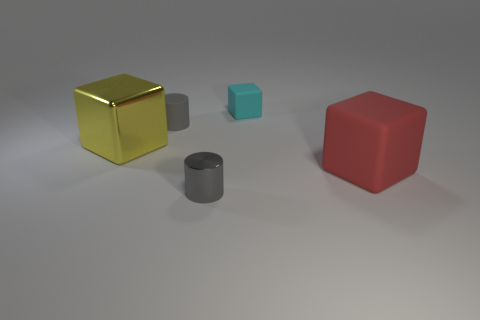Add 4 large yellow metallic balls. How many objects exist? 9 Subtract all cylinders. How many objects are left? 3 Subtract all tiny brown matte spheres. Subtract all big shiny blocks. How many objects are left? 4 Add 4 cyan cubes. How many cyan cubes are left? 5 Add 2 small gray matte things. How many small gray matte things exist? 3 Subtract 0 cyan cylinders. How many objects are left? 5 